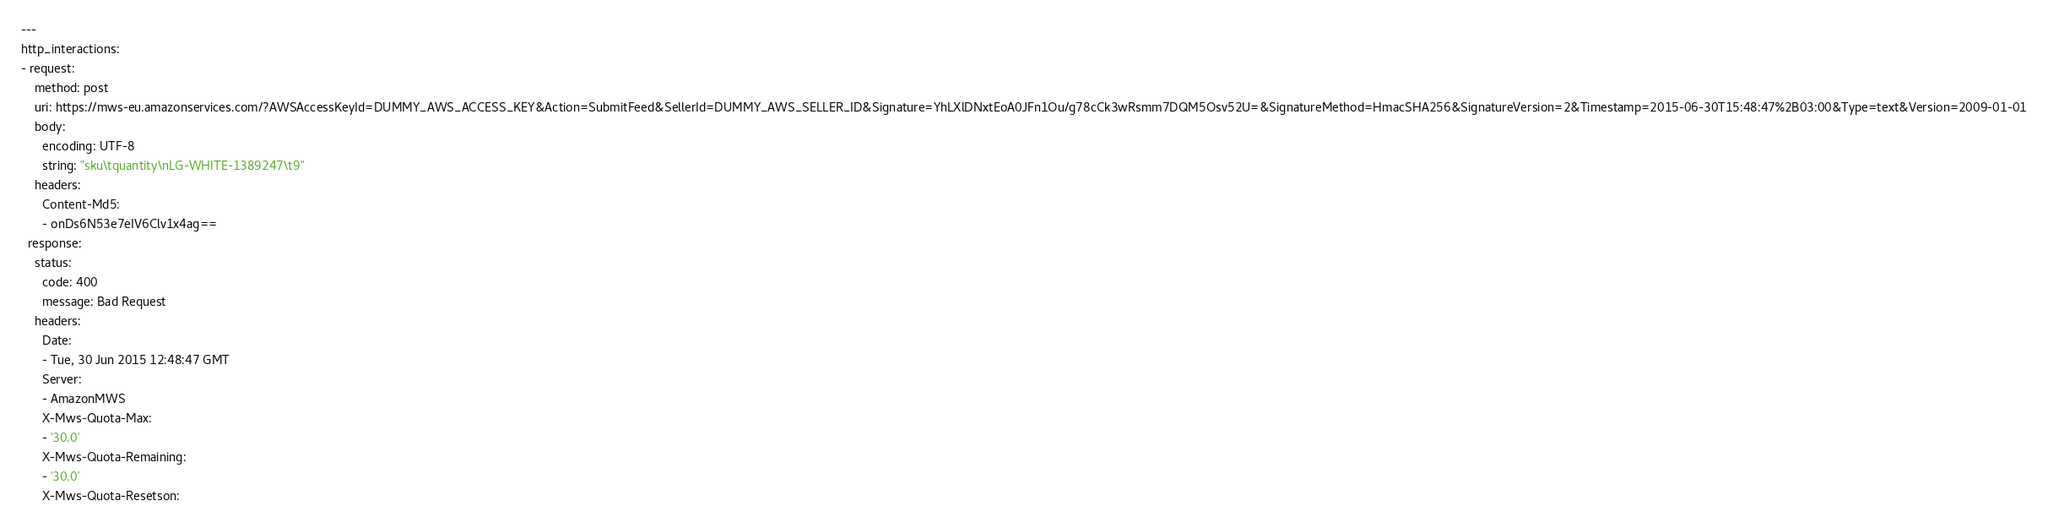Convert code to text. <code><loc_0><loc_0><loc_500><loc_500><_YAML_>---
http_interactions:
- request:
    method: post
    uri: https://mws-eu.amazonservices.com/?AWSAccessKeyId=DUMMY_AWS_ACCESS_KEY&Action=SubmitFeed&SellerId=DUMMY_AWS_SELLER_ID&Signature=YhLXlDNxtEoA0JFn1Ou/g78cCk3wRsmm7DQM5Osv52U=&SignatureMethod=HmacSHA256&SignatureVersion=2&Timestamp=2015-06-30T15:48:47%2B03:00&Type=text&Version=2009-01-01
    body:
      encoding: UTF-8
      string: "sku\tquantity\nLG-WHITE-1389247\t9"
    headers:
      Content-Md5:
      - onDs6N53e7eIV6Clv1x4ag==
  response:
    status:
      code: 400
      message: Bad Request
    headers:
      Date:
      - Tue, 30 Jun 2015 12:48:47 GMT
      Server:
      - AmazonMWS
      X-Mws-Quota-Max:
      - '30.0'
      X-Mws-Quota-Remaining:
      - '30.0'
      X-Mws-Quota-Resetson:</code> 